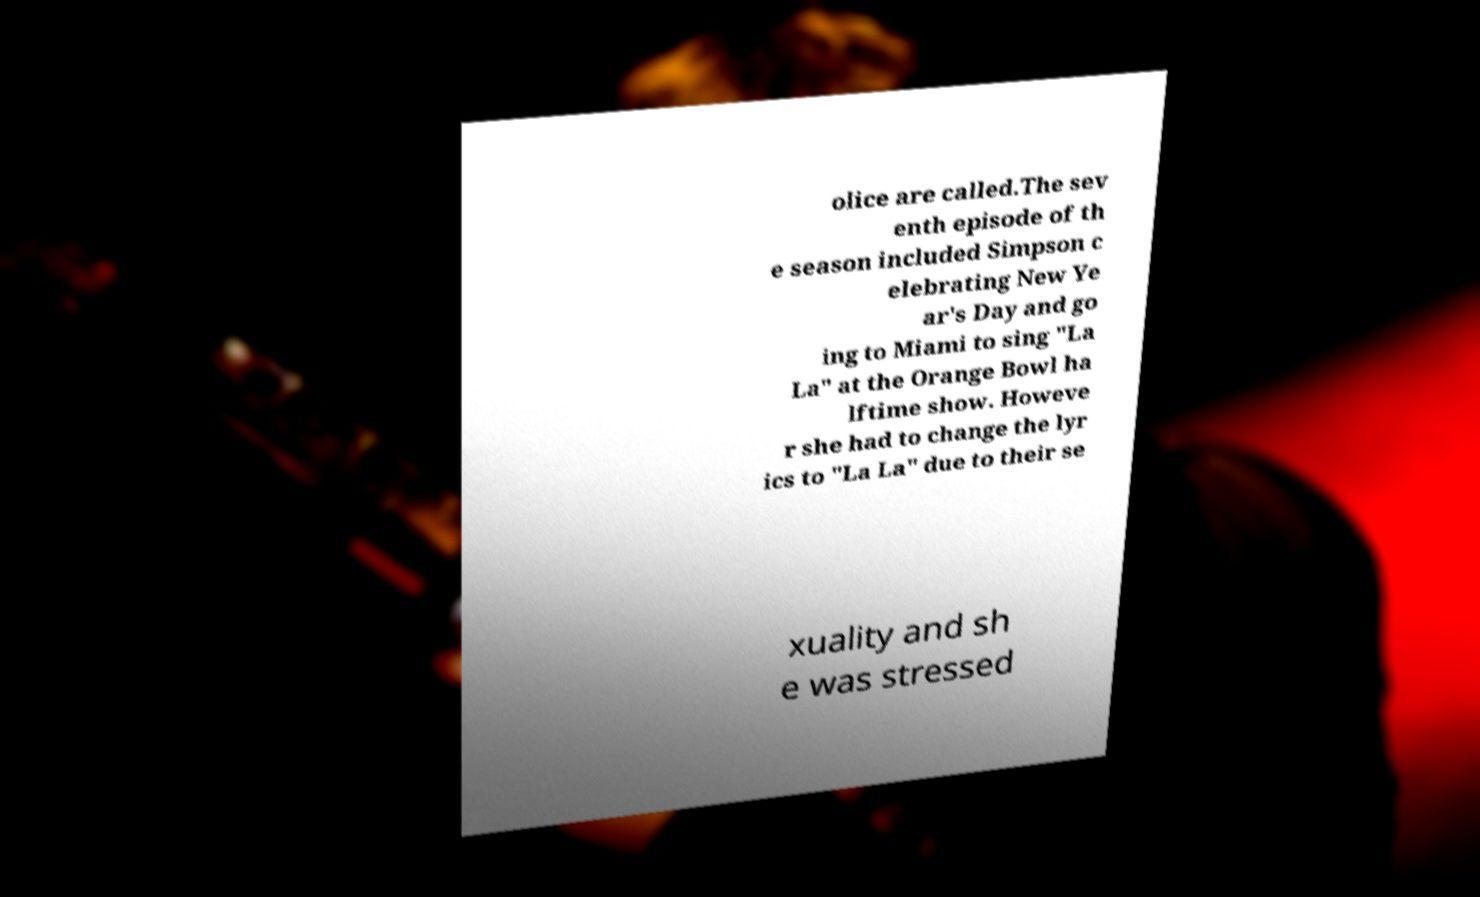Can you accurately transcribe the text from the provided image for me? olice are called.The sev enth episode of th e season included Simpson c elebrating New Ye ar's Day and go ing to Miami to sing "La La" at the Orange Bowl ha lftime show. Howeve r she had to change the lyr ics to "La La" due to their se xuality and sh e was stressed 